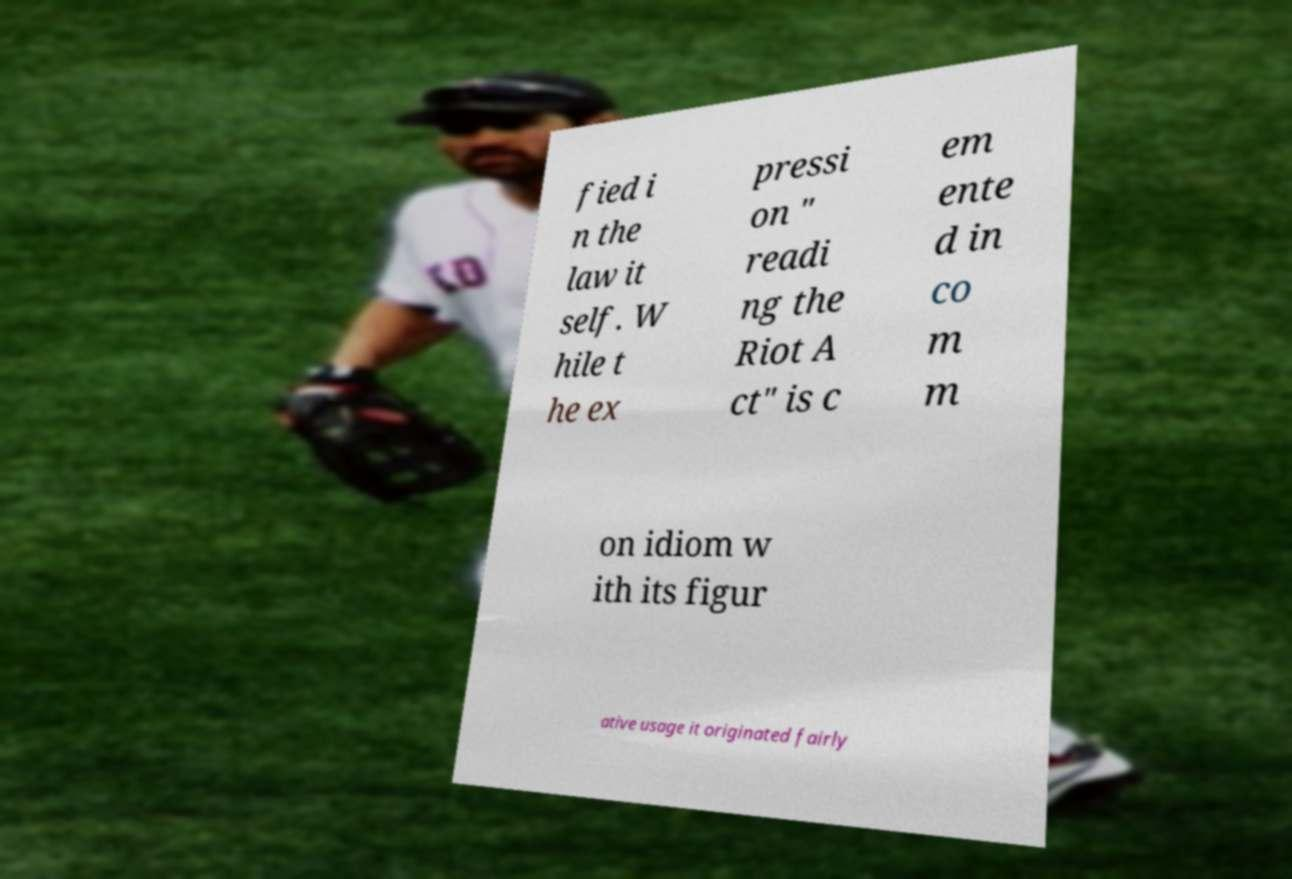There's text embedded in this image that I need extracted. Can you transcribe it verbatim? fied i n the law it self. W hile t he ex pressi on " readi ng the Riot A ct" is c em ente d in co m m on idiom w ith its figur ative usage it originated fairly 